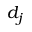<formula> <loc_0><loc_0><loc_500><loc_500>d _ { j }</formula> 